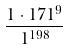Convert formula to latex. <formula><loc_0><loc_0><loc_500><loc_500>\frac { 1 \cdot 1 7 1 ^ { 9 } } { 1 ^ { 1 9 8 } }</formula> 